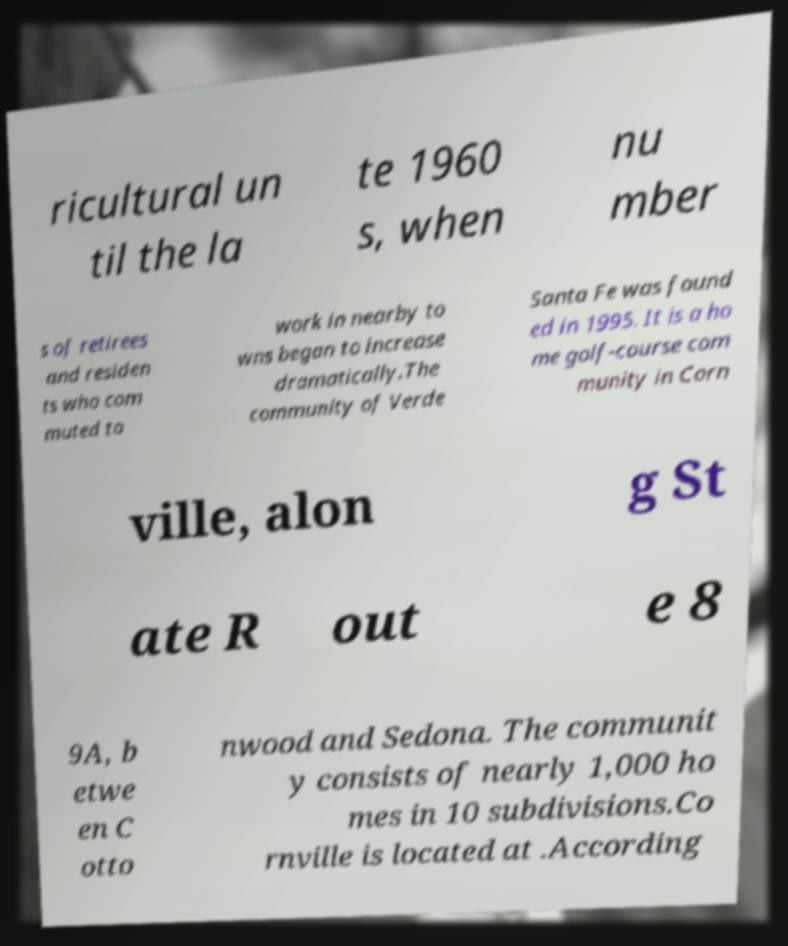For documentation purposes, I need the text within this image transcribed. Could you provide that? ricultural un til the la te 1960 s, when nu mber s of retirees and residen ts who com muted to work in nearby to wns began to increase dramatically.The community of Verde Santa Fe was found ed in 1995. It is a ho me golf-course com munity in Corn ville, alon g St ate R out e 8 9A, b etwe en C otto nwood and Sedona. The communit y consists of nearly 1,000 ho mes in 10 subdivisions.Co rnville is located at .According 